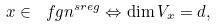Convert formula to latex. <formula><loc_0><loc_0><loc_500><loc_500>x \in \ f g n ^ { s r e g } \Leftrightarrow \dim V _ { x } = d ,</formula> 